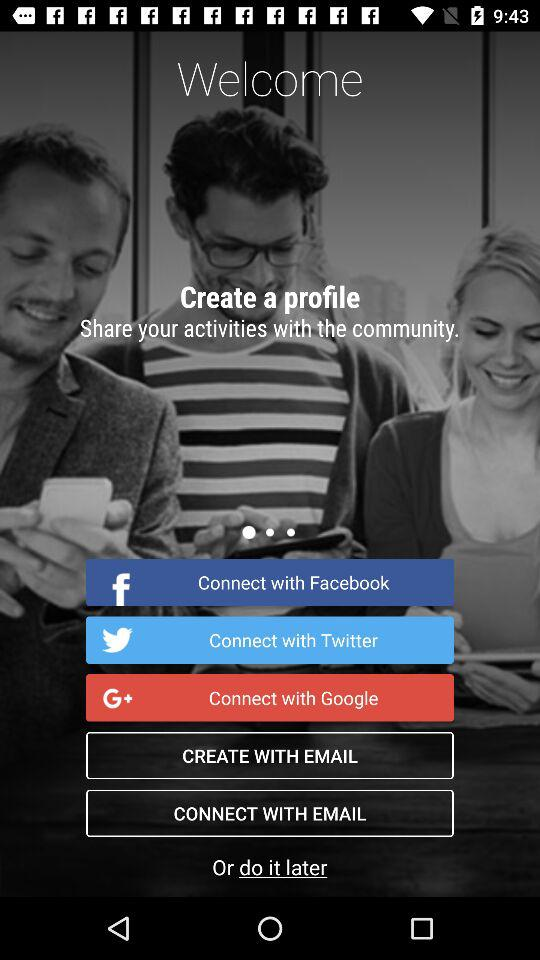What accounts can I use to sign up? You can use "Facebook", "Twitter", "Google" and "EMAIL" accounts to sign up. 